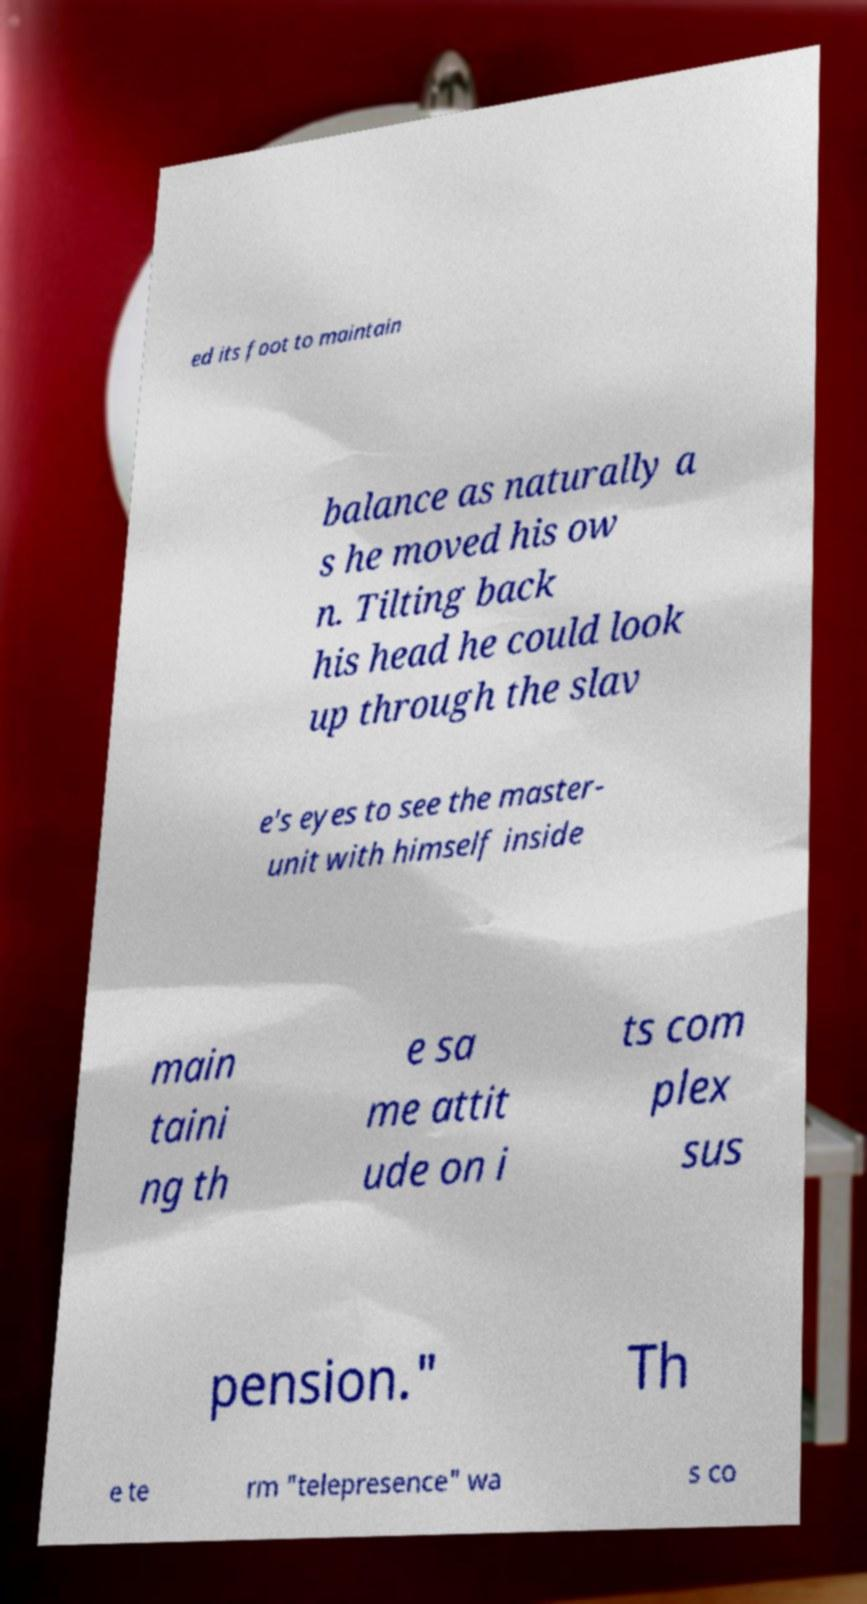For documentation purposes, I need the text within this image transcribed. Could you provide that? ed its foot to maintain balance as naturally a s he moved his ow n. Tilting back his head he could look up through the slav e's eyes to see the master- unit with himself inside main taini ng th e sa me attit ude on i ts com plex sus pension." Th e te rm "telepresence" wa s co 